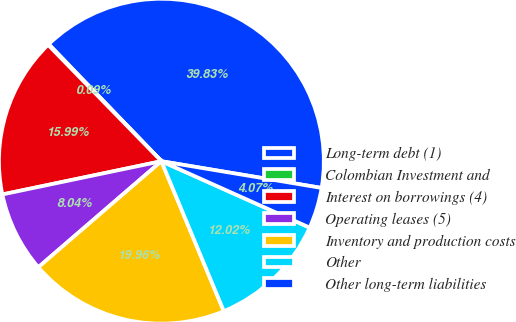<chart> <loc_0><loc_0><loc_500><loc_500><pie_chart><fcel>Long-term debt (1)<fcel>Colombian Investment and<fcel>Interest on borrowings (4)<fcel>Operating leases (5)<fcel>Inventory and production costs<fcel>Other<fcel>Other long-term liabilities<nl><fcel>39.83%<fcel>0.09%<fcel>15.99%<fcel>8.04%<fcel>19.96%<fcel>12.02%<fcel>4.07%<nl></chart> 